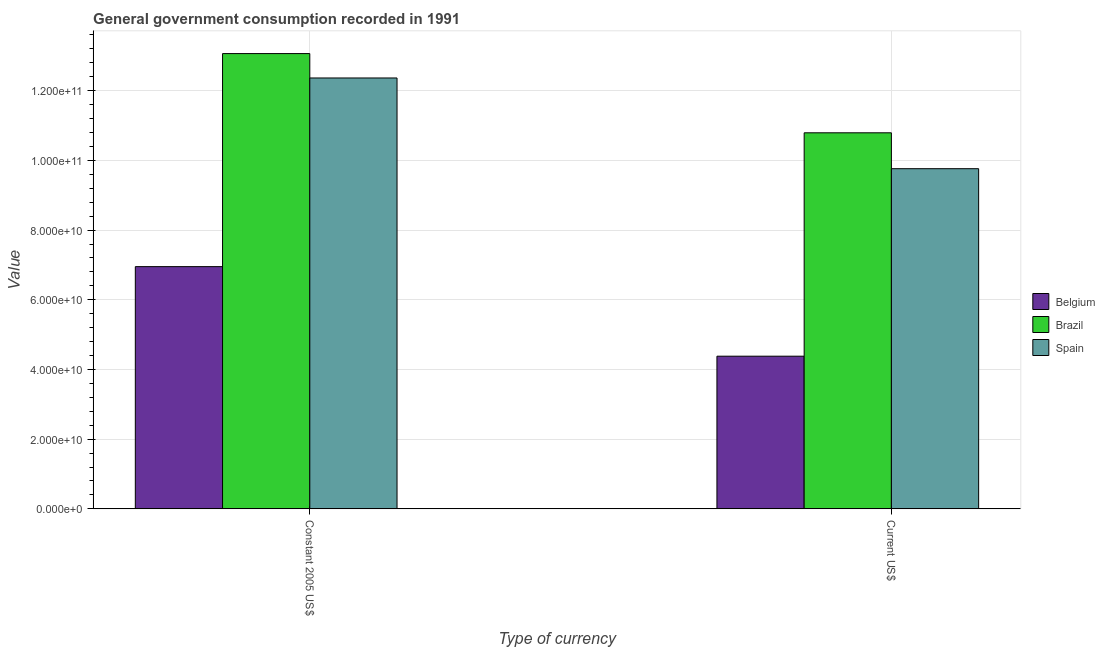Are the number of bars on each tick of the X-axis equal?
Keep it short and to the point. Yes. How many bars are there on the 1st tick from the right?
Provide a short and direct response. 3. What is the label of the 2nd group of bars from the left?
Keep it short and to the point. Current US$. What is the value consumed in constant 2005 us$ in Belgium?
Give a very brief answer. 6.95e+1. Across all countries, what is the maximum value consumed in current us$?
Your response must be concise. 1.08e+11. Across all countries, what is the minimum value consumed in current us$?
Keep it short and to the point. 4.38e+1. In which country was the value consumed in constant 2005 us$ maximum?
Ensure brevity in your answer.  Brazil. What is the total value consumed in current us$ in the graph?
Make the answer very short. 2.49e+11. What is the difference between the value consumed in current us$ in Belgium and that in Spain?
Your response must be concise. -5.38e+1. What is the difference between the value consumed in constant 2005 us$ in Belgium and the value consumed in current us$ in Spain?
Offer a very short reply. -2.81e+1. What is the average value consumed in current us$ per country?
Ensure brevity in your answer.  8.31e+1. What is the difference between the value consumed in current us$ and value consumed in constant 2005 us$ in Spain?
Your answer should be very brief. -2.60e+1. What is the ratio of the value consumed in current us$ in Brazil to that in Spain?
Your answer should be compact. 1.11. What does the 3rd bar from the left in Constant 2005 US$ represents?
Your response must be concise. Spain. How many bars are there?
Offer a very short reply. 6. How many countries are there in the graph?
Keep it short and to the point. 3. Where does the legend appear in the graph?
Provide a short and direct response. Center right. How many legend labels are there?
Ensure brevity in your answer.  3. What is the title of the graph?
Ensure brevity in your answer.  General government consumption recorded in 1991. What is the label or title of the X-axis?
Keep it short and to the point. Type of currency. What is the label or title of the Y-axis?
Provide a succinct answer. Value. What is the Value in Belgium in Constant 2005 US$?
Ensure brevity in your answer.  6.95e+1. What is the Value in Brazil in Constant 2005 US$?
Ensure brevity in your answer.  1.31e+11. What is the Value of Spain in Constant 2005 US$?
Make the answer very short. 1.24e+11. What is the Value in Belgium in Current US$?
Your answer should be very brief. 4.38e+1. What is the Value in Brazil in Current US$?
Make the answer very short. 1.08e+11. What is the Value in Spain in Current US$?
Ensure brevity in your answer.  9.76e+1. Across all Type of currency, what is the maximum Value of Belgium?
Your answer should be very brief. 6.95e+1. Across all Type of currency, what is the maximum Value of Brazil?
Keep it short and to the point. 1.31e+11. Across all Type of currency, what is the maximum Value of Spain?
Give a very brief answer. 1.24e+11. Across all Type of currency, what is the minimum Value in Belgium?
Your response must be concise. 4.38e+1. Across all Type of currency, what is the minimum Value of Brazil?
Your response must be concise. 1.08e+11. Across all Type of currency, what is the minimum Value in Spain?
Give a very brief answer. 9.76e+1. What is the total Value of Belgium in the graph?
Make the answer very short. 1.13e+11. What is the total Value in Brazil in the graph?
Provide a short and direct response. 2.39e+11. What is the total Value of Spain in the graph?
Your answer should be very brief. 2.21e+11. What is the difference between the Value of Belgium in Constant 2005 US$ and that in Current US$?
Offer a very short reply. 2.57e+1. What is the difference between the Value in Brazil in Constant 2005 US$ and that in Current US$?
Give a very brief answer. 2.27e+1. What is the difference between the Value of Spain in Constant 2005 US$ and that in Current US$?
Make the answer very short. 2.60e+1. What is the difference between the Value of Belgium in Constant 2005 US$ and the Value of Brazil in Current US$?
Give a very brief answer. -3.84e+1. What is the difference between the Value in Belgium in Constant 2005 US$ and the Value in Spain in Current US$?
Offer a very short reply. -2.81e+1. What is the difference between the Value in Brazil in Constant 2005 US$ and the Value in Spain in Current US$?
Provide a succinct answer. 3.30e+1. What is the average Value in Belgium per Type of currency?
Offer a terse response. 5.67e+1. What is the average Value in Brazil per Type of currency?
Offer a very short reply. 1.19e+11. What is the average Value in Spain per Type of currency?
Provide a succinct answer. 1.11e+11. What is the difference between the Value of Belgium and Value of Brazil in Constant 2005 US$?
Keep it short and to the point. -6.11e+1. What is the difference between the Value in Belgium and Value in Spain in Constant 2005 US$?
Ensure brevity in your answer.  -5.41e+1. What is the difference between the Value of Brazil and Value of Spain in Constant 2005 US$?
Your answer should be very brief. 7.00e+09. What is the difference between the Value of Belgium and Value of Brazil in Current US$?
Ensure brevity in your answer.  -6.41e+1. What is the difference between the Value of Belgium and Value of Spain in Current US$?
Your answer should be very brief. -5.38e+1. What is the difference between the Value in Brazil and Value in Spain in Current US$?
Your answer should be compact. 1.03e+1. What is the ratio of the Value in Belgium in Constant 2005 US$ to that in Current US$?
Ensure brevity in your answer.  1.59. What is the ratio of the Value in Brazil in Constant 2005 US$ to that in Current US$?
Make the answer very short. 1.21. What is the ratio of the Value of Spain in Constant 2005 US$ to that in Current US$?
Your answer should be compact. 1.27. What is the difference between the highest and the second highest Value in Belgium?
Make the answer very short. 2.57e+1. What is the difference between the highest and the second highest Value in Brazil?
Your answer should be very brief. 2.27e+1. What is the difference between the highest and the second highest Value of Spain?
Offer a very short reply. 2.60e+1. What is the difference between the highest and the lowest Value of Belgium?
Your answer should be very brief. 2.57e+1. What is the difference between the highest and the lowest Value in Brazil?
Your answer should be very brief. 2.27e+1. What is the difference between the highest and the lowest Value in Spain?
Keep it short and to the point. 2.60e+1. 